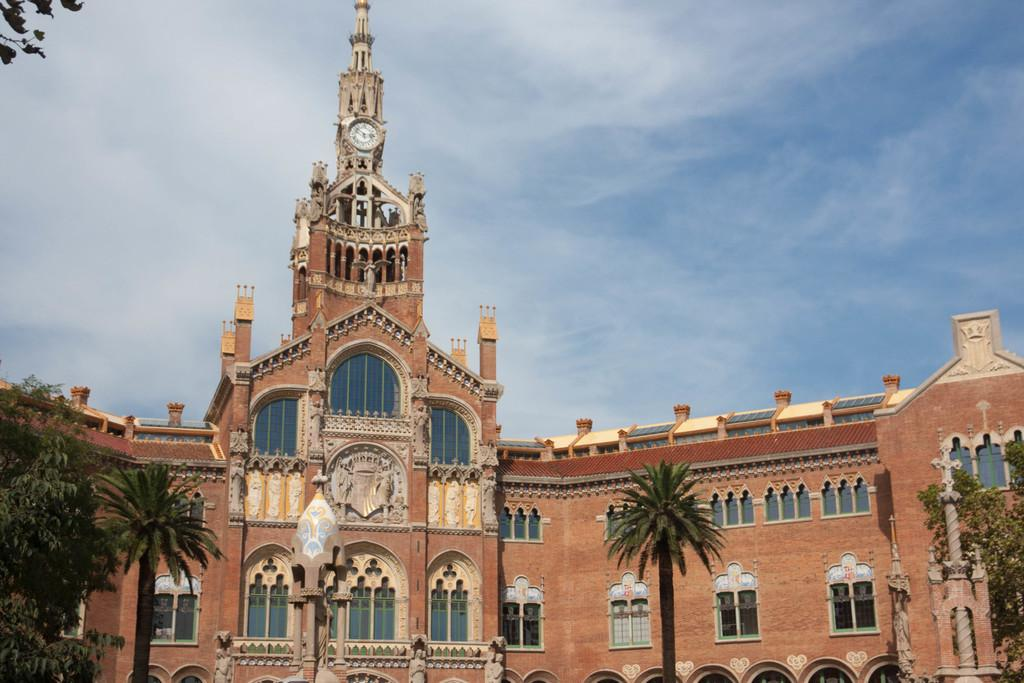What type of vegetation can be seen in the image? There are trees in the image. What type of structure is present in the image? There is a building in the image. What part of the natural environment is visible in the image? The sky is visible in the background of the image. What note is the minister playing on the piano in the image? There is no piano or minister present in the image. 